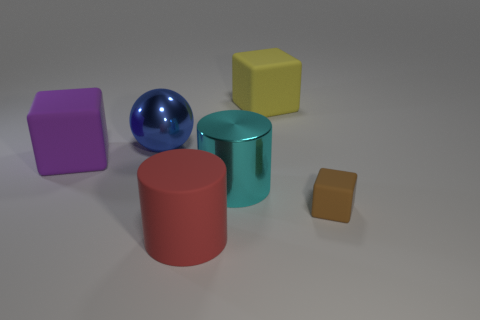Is there a yellow rubber cube that has the same size as the ball?
Your answer should be compact. Yes. Are there fewer large yellow objects than small cyan cylinders?
Your answer should be compact. No. The metallic thing behind the large metallic object that is in front of the rubber block to the left of the blue metal thing is what shape?
Your response must be concise. Sphere. How many things are either cyan objects that are to the left of the yellow object or large matte things in front of the large blue object?
Your answer should be very brief. 3. Are there any things in front of the large blue metallic sphere?
Provide a short and direct response. Yes. How many objects are large objects that are right of the red cylinder or small cyan metallic balls?
Your answer should be compact. 2. What number of yellow objects are either big cubes or matte cylinders?
Ensure brevity in your answer.  1. How many other objects are there of the same color as the large metallic cylinder?
Provide a succinct answer. 0. Are there fewer big blue metal spheres that are right of the yellow matte block than big yellow blocks?
Your answer should be very brief. Yes. The big matte block that is on the left side of the large rubber cube to the right of the blue metal object behind the large purple rubber thing is what color?
Give a very brief answer. Purple. 